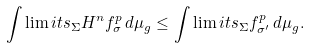Convert formula to latex. <formula><loc_0><loc_0><loc_500><loc_500>\int \lim i t s _ { \Sigma } H ^ { n } f _ { \sigma } ^ { p } \, d \mu _ { g } \leq \int \lim i t s _ { \Sigma } f _ { \sigma ^ { \prime } } ^ { p } \, d \mu _ { g } .</formula> 